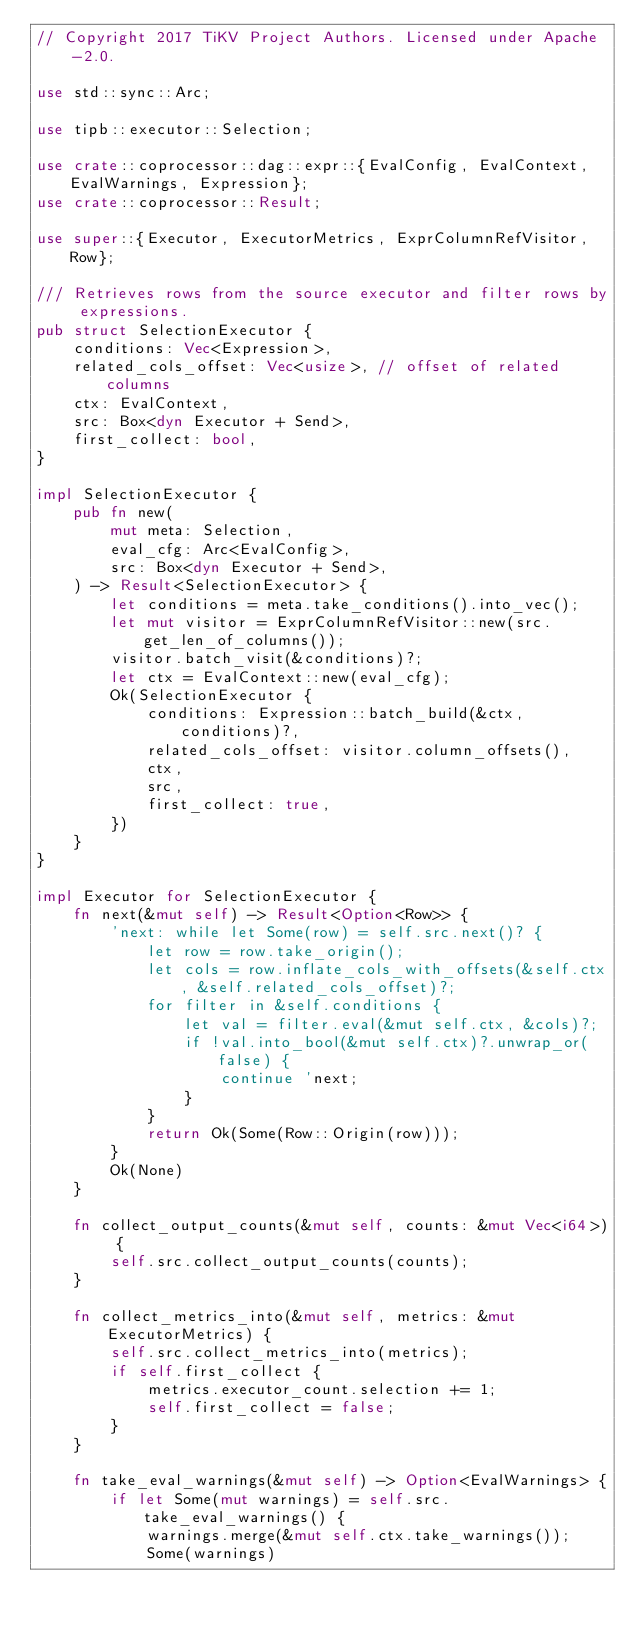Convert code to text. <code><loc_0><loc_0><loc_500><loc_500><_Rust_>// Copyright 2017 TiKV Project Authors. Licensed under Apache-2.0.

use std::sync::Arc;

use tipb::executor::Selection;

use crate::coprocessor::dag::expr::{EvalConfig, EvalContext, EvalWarnings, Expression};
use crate::coprocessor::Result;

use super::{Executor, ExecutorMetrics, ExprColumnRefVisitor, Row};

/// Retrieves rows from the source executor and filter rows by expressions.
pub struct SelectionExecutor {
    conditions: Vec<Expression>,
    related_cols_offset: Vec<usize>, // offset of related columns
    ctx: EvalContext,
    src: Box<dyn Executor + Send>,
    first_collect: bool,
}

impl SelectionExecutor {
    pub fn new(
        mut meta: Selection,
        eval_cfg: Arc<EvalConfig>,
        src: Box<dyn Executor + Send>,
    ) -> Result<SelectionExecutor> {
        let conditions = meta.take_conditions().into_vec();
        let mut visitor = ExprColumnRefVisitor::new(src.get_len_of_columns());
        visitor.batch_visit(&conditions)?;
        let ctx = EvalContext::new(eval_cfg);
        Ok(SelectionExecutor {
            conditions: Expression::batch_build(&ctx, conditions)?,
            related_cols_offset: visitor.column_offsets(),
            ctx,
            src,
            first_collect: true,
        })
    }
}

impl Executor for SelectionExecutor {
    fn next(&mut self) -> Result<Option<Row>> {
        'next: while let Some(row) = self.src.next()? {
            let row = row.take_origin();
            let cols = row.inflate_cols_with_offsets(&self.ctx, &self.related_cols_offset)?;
            for filter in &self.conditions {
                let val = filter.eval(&mut self.ctx, &cols)?;
                if !val.into_bool(&mut self.ctx)?.unwrap_or(false) {
                    continue 'next;
                }
            }
            return Ok(Some(Row::Origin(row)));
        }
        Ok(None)
    }

    fn collect_output_counts(&mut self, counts: &mut Vec<i64>) {
        self.src.collect_output_counts(counts);
    }

    fn collect_metrics_into(&mut self, metrics: &mut ExecutorMetrics) {
        self.src.collect_metrics_into(metrics);
        if self.first_collect {
            metrics.executor_count.selection += 1;
            self.first_collect = false;
        }
    }

    fn take_eval_warnings(&mut self) -> Option<EvalWarnings> {
        if let Some(mut warnings) = self.src.take_eval_warnings() {
            warnings.merge(&mut self.ctx.take_warnings());
            Some(warnings)</code> 